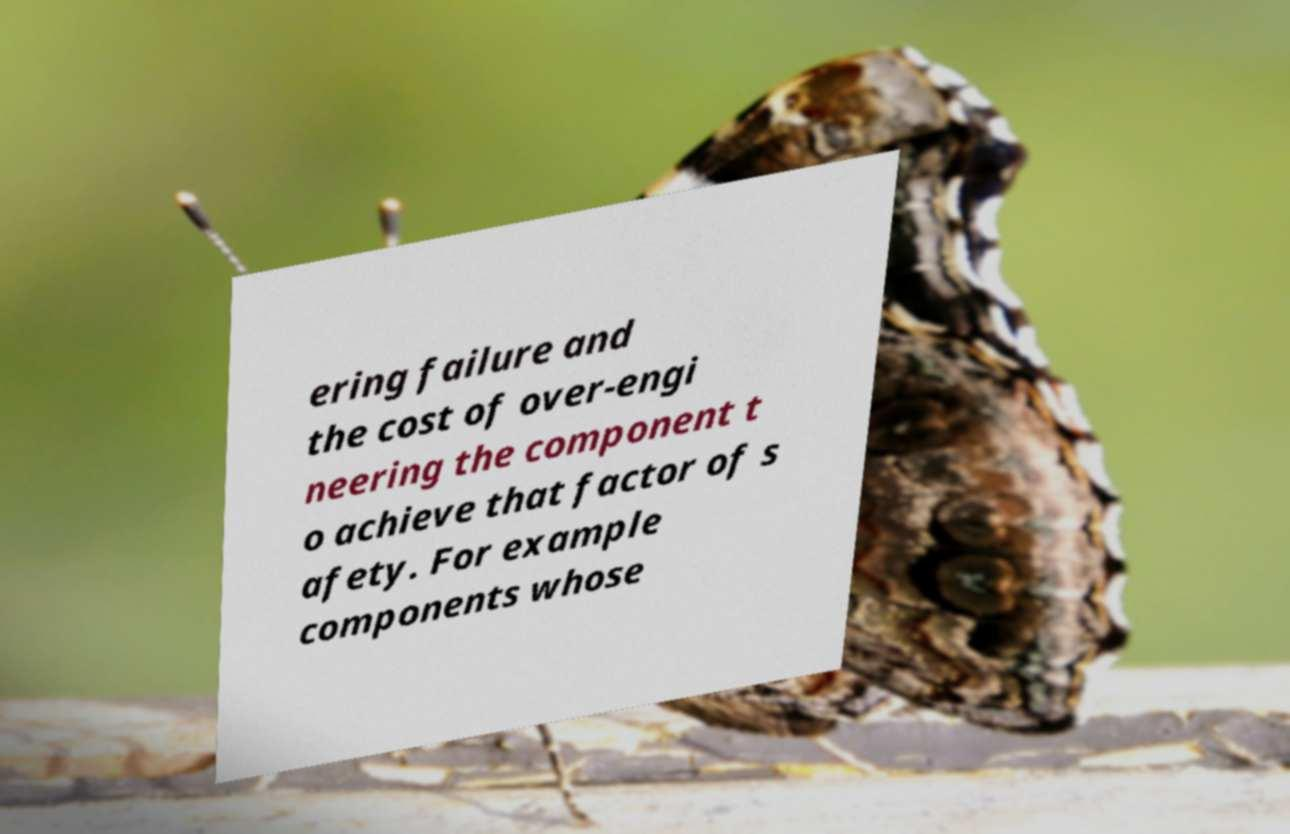Can you read and provide the text displayed in the image?This photo seems to have some interesting text. Can you extract and type it out for me? ering failure and the cost of over-engi neering the component t o achieve that factor of s afety. For example components whose 